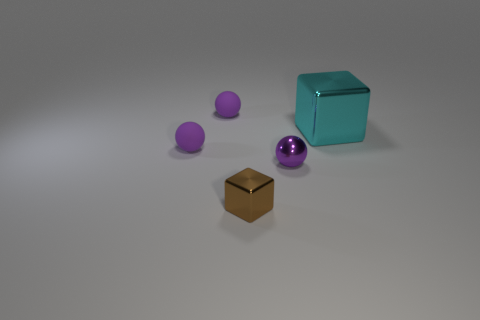Subtract all purple matte balls. How many balls are left? 1 Add 2 large shiny things. How many objects exist? 7 Subtract all brown cubes. How many cubes are left? 1 Subtract all balls. How many objects are left? 2 Add 2 cyan metal objects. How many cyan metal objects exist? 3 Subtract 0 purple blocks. How many objects are left? 5 Subtract 1 cubes. How many cubes are left? 1 Subtract all green balls. Subtract all cyan cubes. How many balls are left? 3 Subtract all purple cylinders. How many cyan cubes are left? 1 Subtract all small matte balls. Subtract all purple rubber balls. How many objects are left? 1 